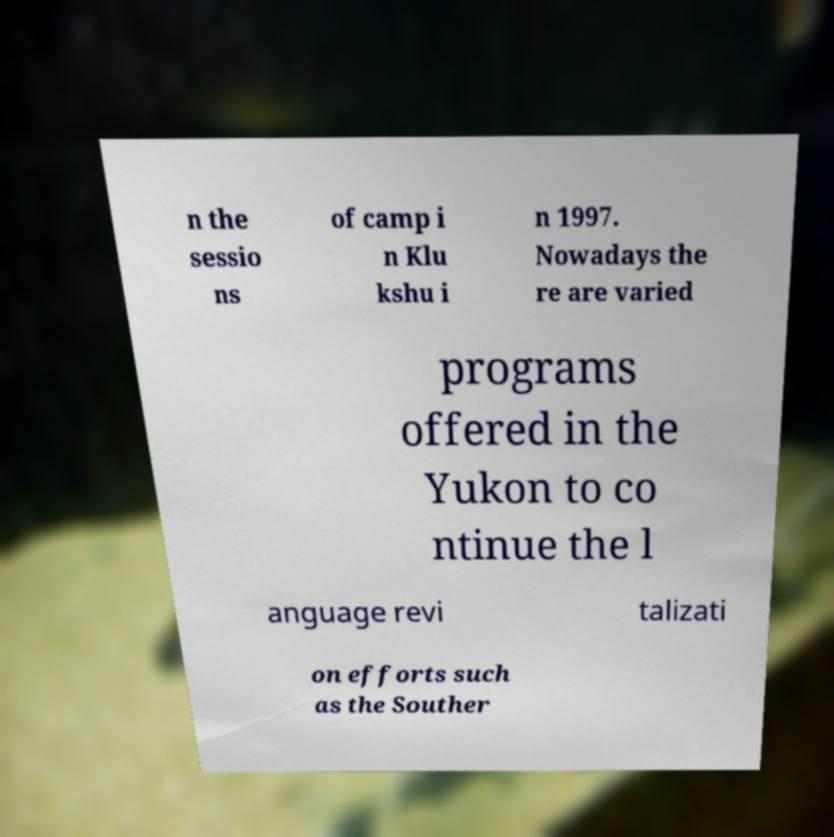Can you accurately transcribe the text from the provided image for me? n the sessio ns of camp i n Klu kshu i n 1997. Nowadays the re are varied programs offered in the Yukon to co ntinue the l anguage revi talizati on efforts such as the Souther 